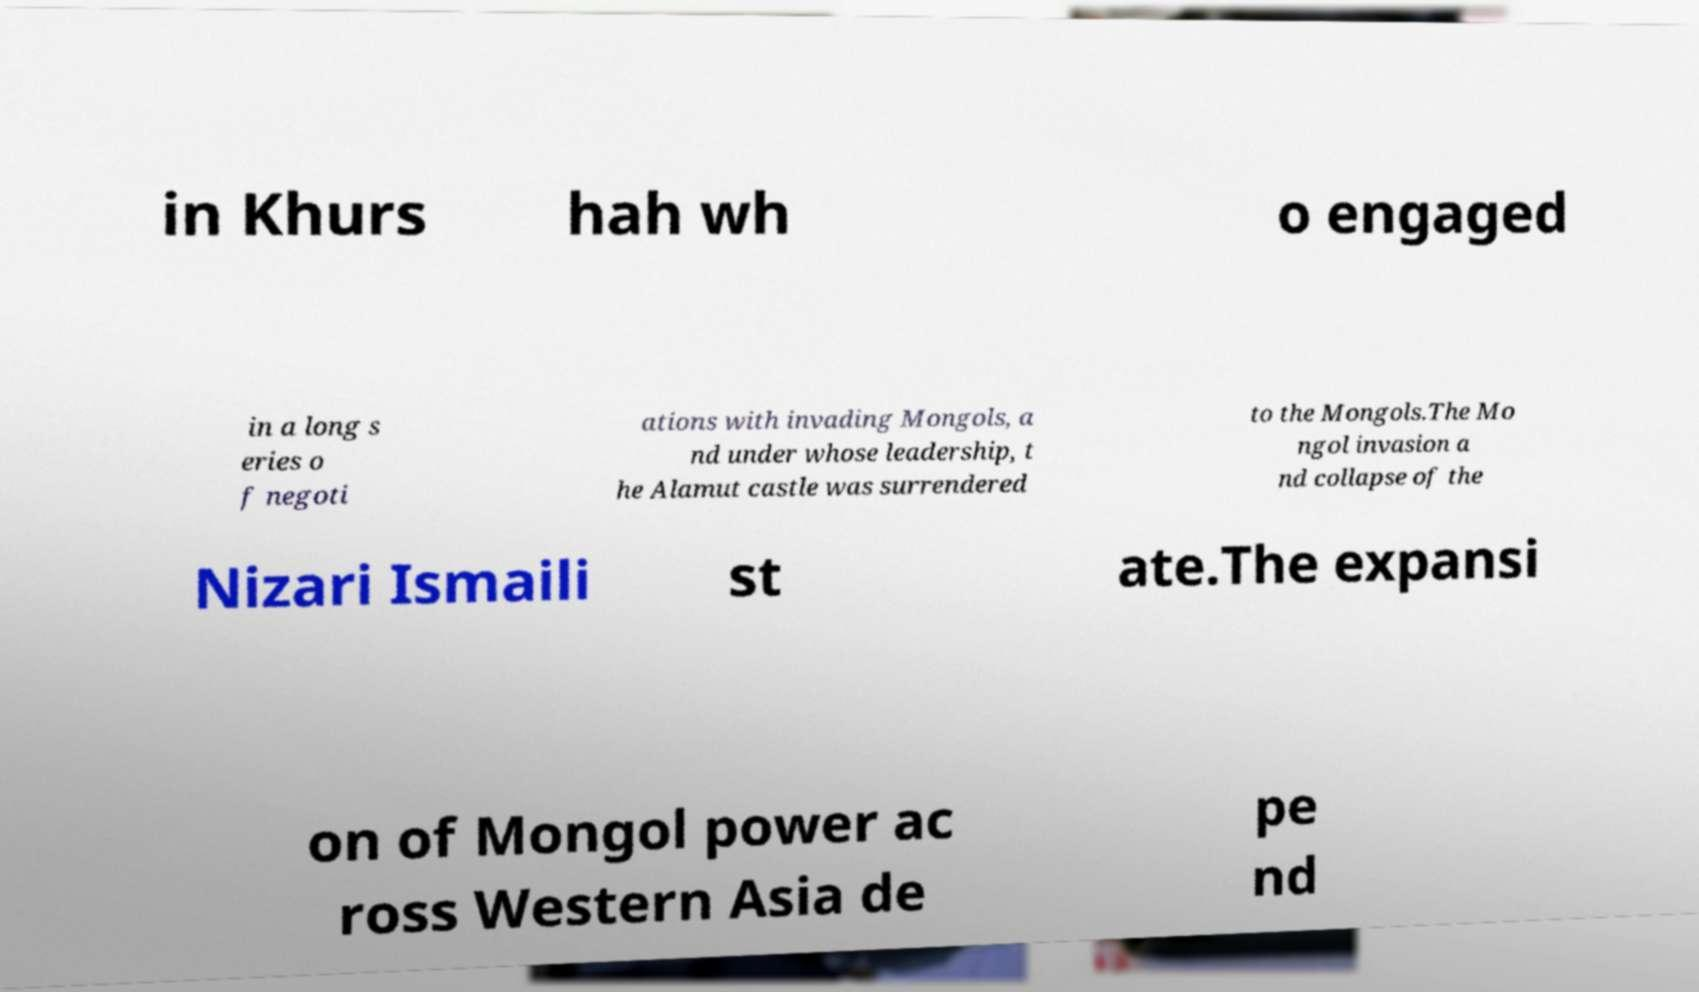Please read and relay the text visible in this image. What does it say? in Khurs hah wh o engaged in a long s eries o f negoti ations with invading Mongols, a nd under whose leadership, t he Alamut castle was surrendered to the Mongols.The Mo ngol invasion a nd collapse of the Nizari Ismaili st ate.The expansi on of Mongol power ac ross Western Asia de pe nd 